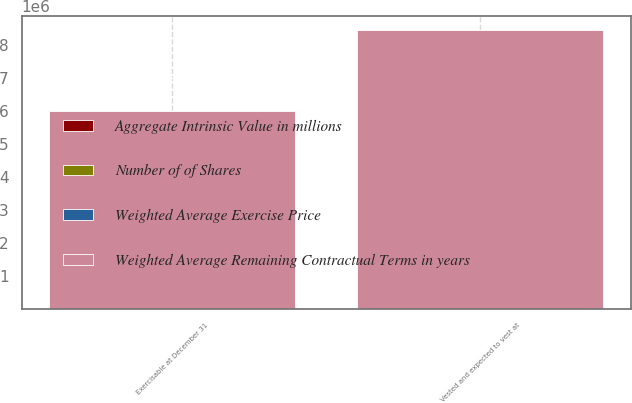Convert chart. <chart><loc_0><loc_0><loc_500><loc_500><stacked_bar_chart><ecel><fcel>Vested and expected to vest at<fcel>Exercisable at December 31<nl><fcel>Weighted Average Remaining Contractual Terms in years<fcel>8.44596e+06<fcel>5.99259e+06<nl><fcel>Aggregate Intrinsic Value in millions<fcel>33.71<fcel>29.16<nl><fcel>Weighted Average Exercise Price<fcel>5.5<fcel>4.4<nl><fcel>Number of of Shares<fcel>273<fcel>221<nl></chart> 